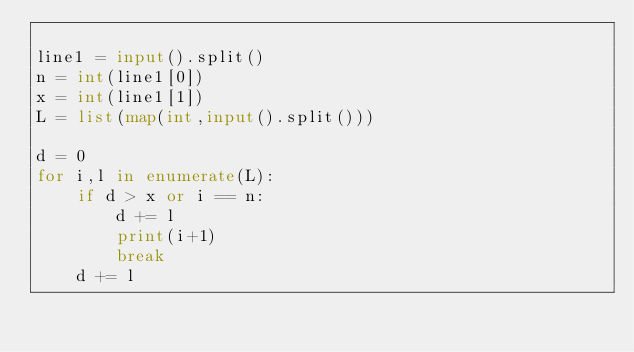<code> <loc_0><loc_0><loc_500><loc_500><_Python_>
line1 = input().split()
n = int(line1[0])
x = int(line1[1])
L = list(map(int,input().split()))

d = 0
for i,l in enumerate(L):
	if d > x or i == n:
		d += l
		print(i+1)
		break
	d += l
</code> 